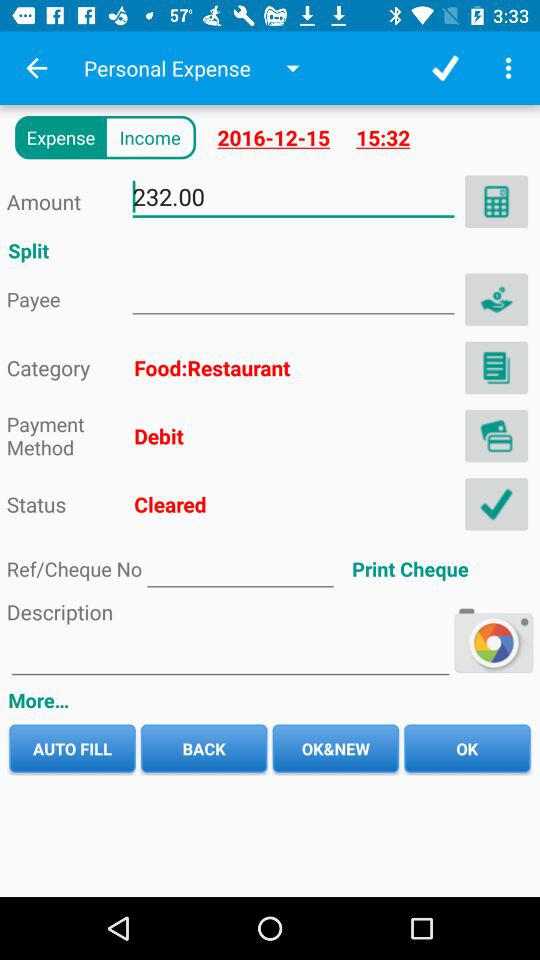What is the status? The status is "Cleared". 